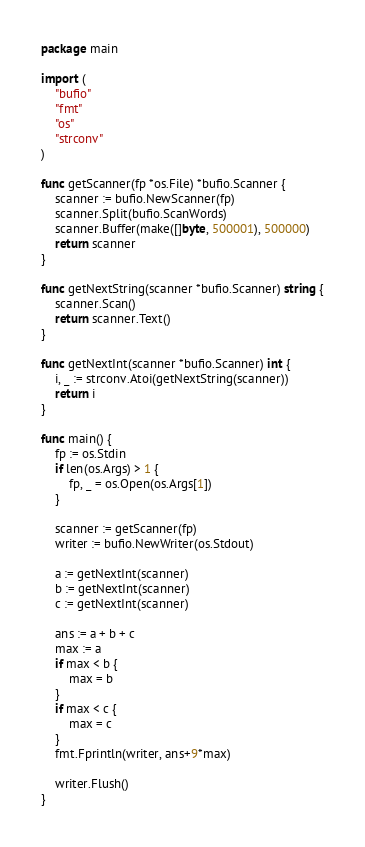Convert code to text. <code><loc_0><loc_0><loc_500><loc_500><_Go_>package main

import (
	"bufio"
	"fmt"
	"os"
	"strconv"
)

func getScanner(fp *os.File) *bufio.Scanner {
	scanner := bufio.NewScanner(fp)
	scanner.Split(bufio.ScanWords)
	scanner.Buffer(make([]byte, 500001), 500000)
	return scanner
}

func getNextString(scanner *bufio.Scanner) string {
	scanner.Scan()
	return scanner.Text()
}

func getNextInt(scanner *bufio.Scanner) int {
	i, _ := strconv.Atoi(getNextString(scanner))
	return i
}

func main() {
	fp := os.Stdin
	if len(os.Args) > 1 {
		fp, _ = os.Open(os.Args[1])
	}

	scanner := getScanner(fp)
	writer := bufio.NewWriter(os.Stdout)

	a := getNextInt(scanner)
	b := getNextInt(scanner)
	c := getNextInt(scanner)

	ans := a + b + c
	max := a
	if max < b {
		max = b
	}
	if max < c {
		max = c
	}
	fmt.Fprintln(writer, ans+9*max)

	writer.Flush()
}
</code> 